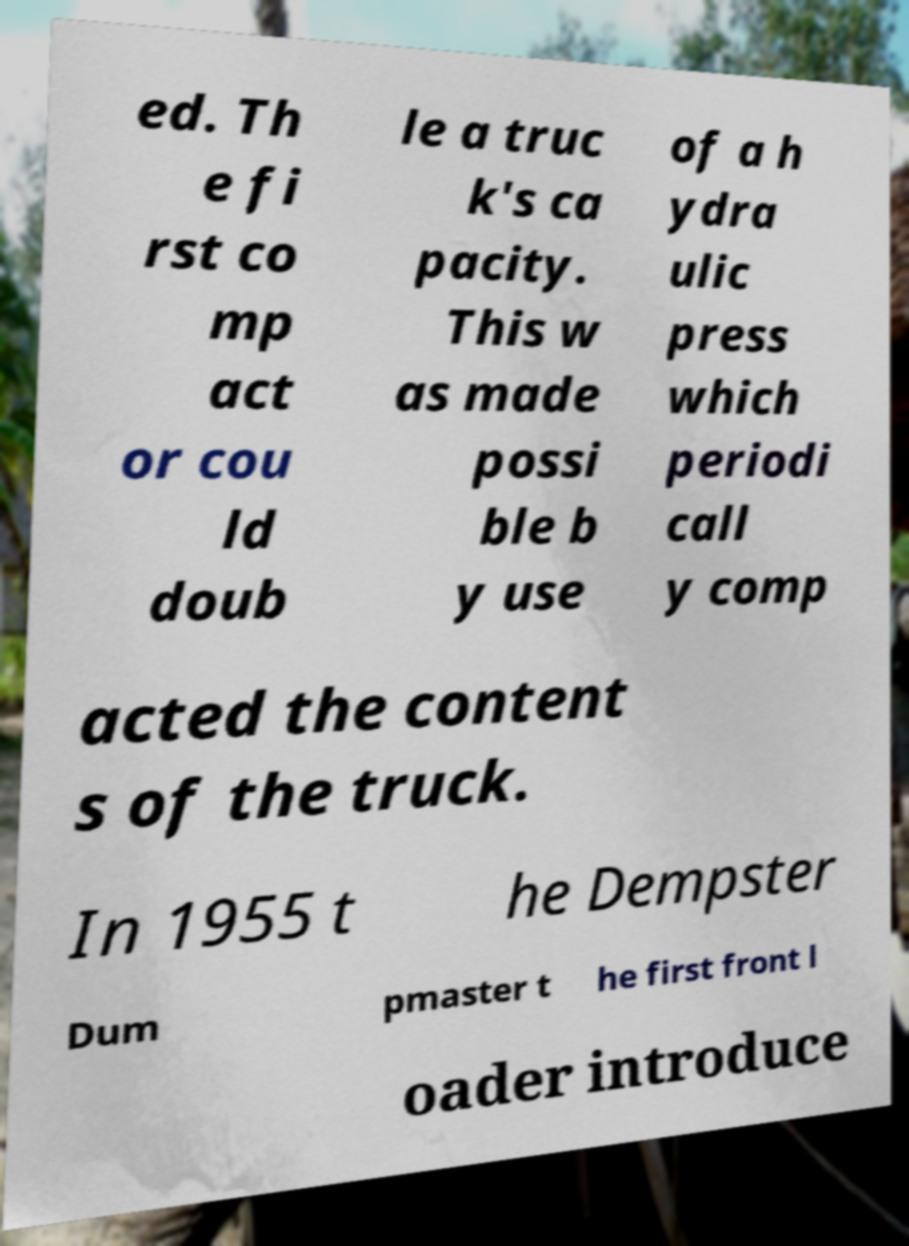Can you read and provide the text displayed in the image?This photo seems to have some interesting text. Can you extract and type it out for me? ed. Th e fi rst co mp act or cou ld doub le a truc k's ca pacity. This w as made possi ble b y use of a h ydra ulic press which periodi call y comp acted the content s of the truck. In 1955 t he Dempster Dum pmaster t he first front l oader introduce 